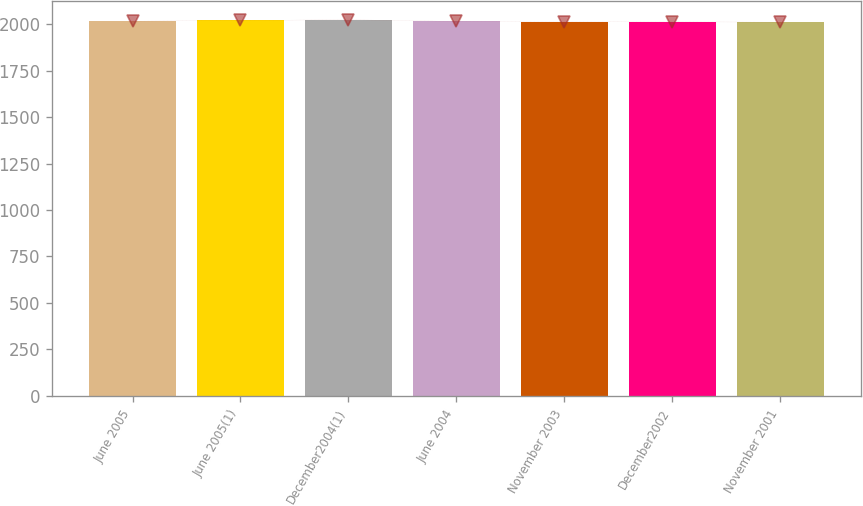Convert chart to OTSL. <chart><loc_0><loc_0><loc_500><loc_500><bar_chart><fcel>June 2005<fcel>June 2005(1)<fcel>December2004(1)<fcel>June 2004<fcel>November 2003<fcel>December2002<fcel>November 2001<nl><fcel>2016.2<fcel>2020<fcel>2024<fcel>2014.9<fcel>2013.6<fcel>2012.3<fcel>2011<nl></chart> 